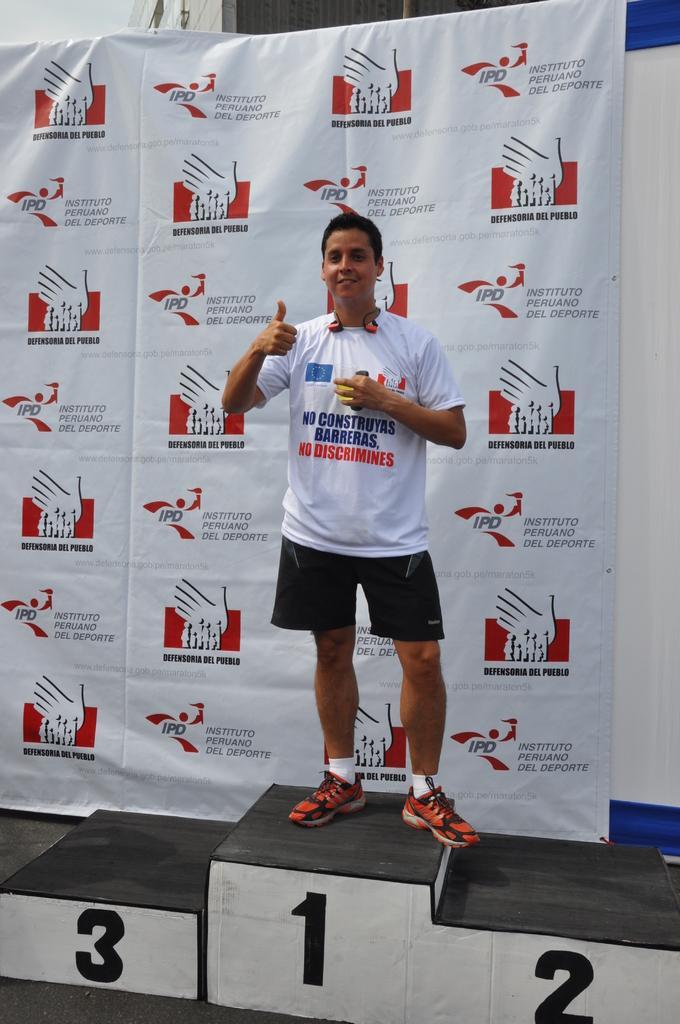Could you give a brief overview of what you see in this image? In this picture I can see a man standing and I can see banner in the back with some logos and text on it and I can see text on the t-shirt and looks like a wall in the back. 